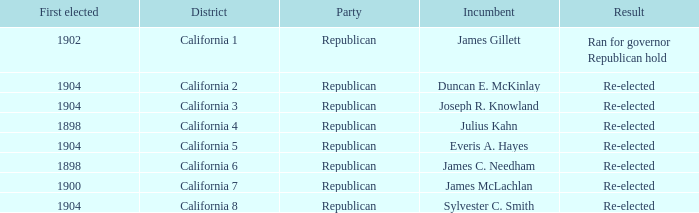Would you be able to parse every entry in this table? {'header': ['First elected', 'District', 'Party', 'Incumbent', 'Result'], 'rows': [['1902', 'California 1', 'Republican', 'James Gillett', 'Ran for governor Republican hold'], ['1904', 'California 2', 'Republican', 'Duncan E. McKinlay', 'Re-elected'], ['1904', 'California 3', 'Republican', 'Joseph R. Knowland', 'Re-elected'], ['1898', 'California 4', 'Republican', 'Julius Kahn', 'Re-elected'], ['1904', 'California 5', 'Republican', 'Everis A. Hayes', 'Re-elected'], ['1898', 'California 6', 'Republican', 'James C. Needham', 'Re-elected'], ['1900', 'California 7', 'Republican', 'James McLachlan', 'Re-elected'], ['1904', 'California 8', 'Republican', 'Sylvester C. Smith', 'Re-elected']]} Which Incumbent has a District of California 5? Everis A. Hayes. 